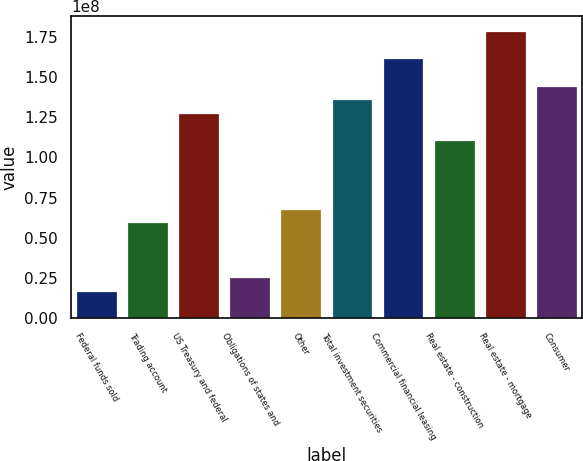Convert chart. <chart><loc_0><loc_0><loc_500><loc_500><bar_chart><fcel>Federal funds sold<fcel>Trading account<fcel>US Treasury and federal<fcel>Obligations of states and<fcel>Other<fcel>Total investment securities<fcel>Commercial financial leasing<fcel>Real estate - construction<fcel>Real estate - mortgage<fcel>Consumer<nl><fcel>1.7086e+07<fcel>5.96337e+07<fcel>1.2771e+08<fcel>2.55955e+07<fcel>6.81433e+07<fcel>1.3622e+08<fcel>1.61748e+08<fcel>1.10691e+08<fcel>1.78767e+08<fcel>1.44729e+08<nl></chart> 